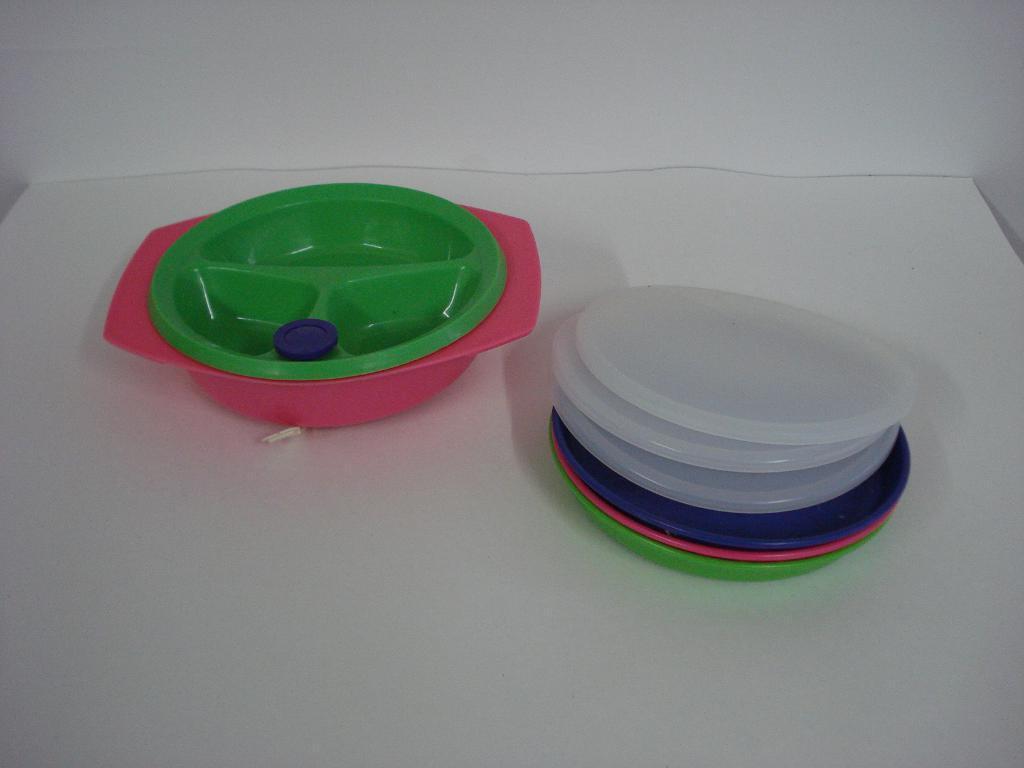Describe this image in one or two sentences. In this image there is an object that looks like table towards the bottom of the image, there are objects on the table, there is a wall towards the top of the image. 